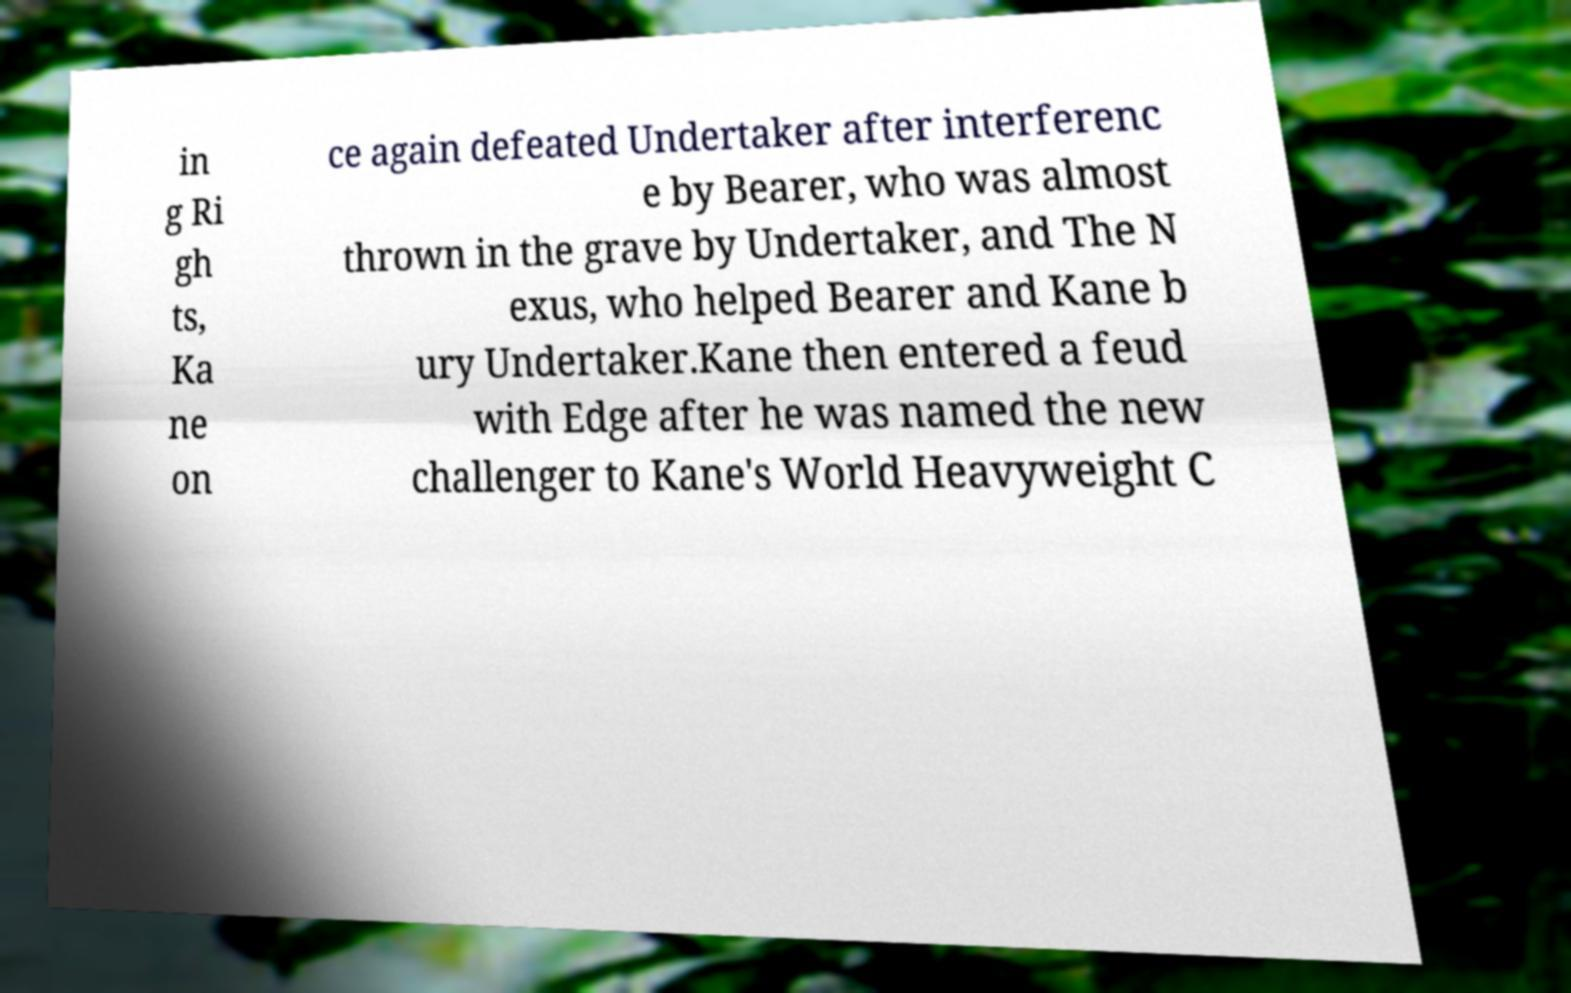There's text embedded in this image that I need extracted. Can you transcribe it verbatim? in g Ri gh ts, Ka ne on ce again defeated Undertaker after interferenc e by Bearer, who was almost thrown in the grave by Undertaker, and The N exus, who helped Bearer and Kane b ury Undertaker.Kane then entered a feud with Edge after he was named the new challenger to Kane's World Heavyweight C 